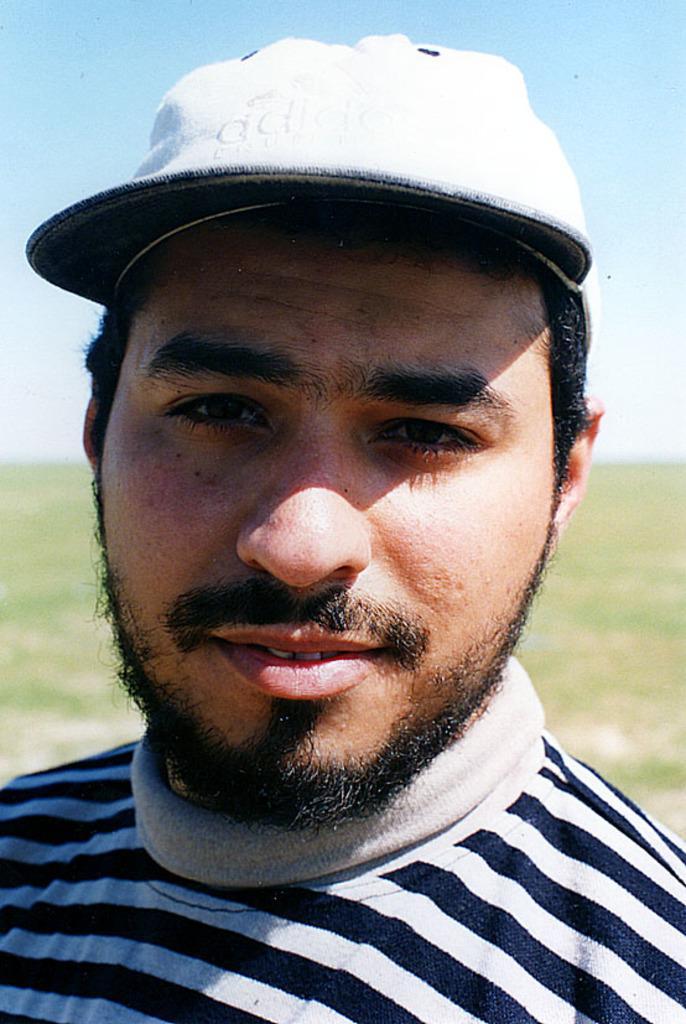In one or two sentences, can you explain what this image depicts? Here we can see a man and he wore a cap. This is ground. In the background we can see sky. 